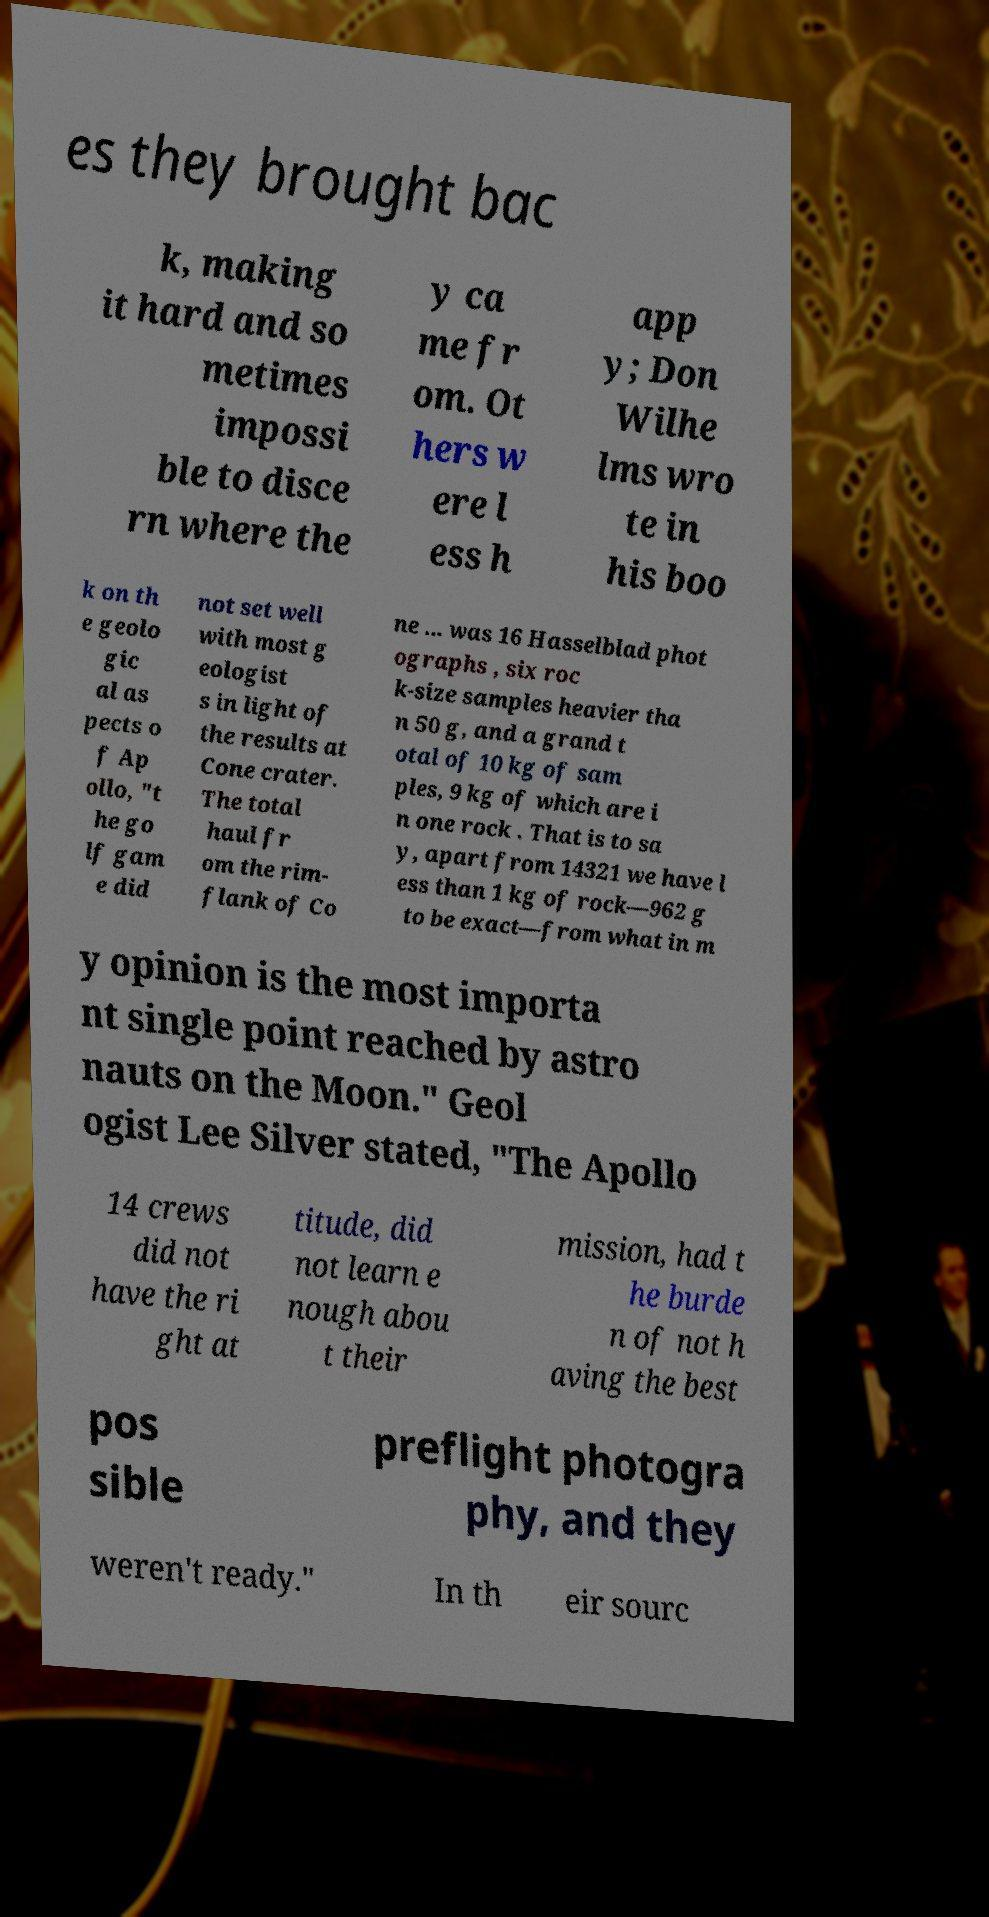Could you extract and type out the text from this image? es they brought bac k, making it hard and so metimes impossi ble to disce rn where the y ca me fr om. Ot hers w ere l ess h app y; Don Wilhe lms wro te in his boo k on th e geolo gic al as pects o f Ap ollo, "t he go lf gam e did not set well with most g eologist s in light of the results at Cone crater. The total haul fr om the rim- flank of Co ne ... was 16 Hasselblad phot ographs , six roc k-size samples heavier tha n 50 g, and a grand t otal of 10 kg of sam ples, 9 kg of which are i n one rock . That is to sa y, apart from 14321 we have l ess than 1 kg of rock—962 g to be exact—from what in m y opinion is the most importa nt single point reached by astro nauts on the Moon." Geol ogist Lee Silver stated, "The Apollo 14 crews did not have the ri ght at titude, did not learn e nough abou t their mission, had t he burde n of not h aving the best pos sible preflight photogra phy, and they weren't ready." In th eir sourc 